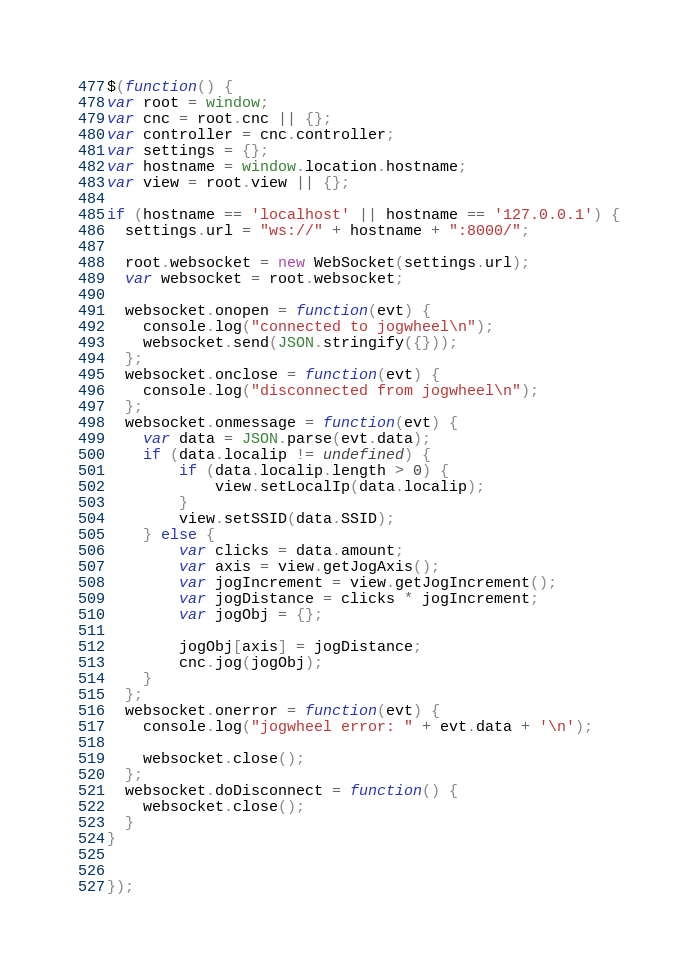<code> <loc_0><loc_0><loc_500><loc_500><_JavaScript_>$(function() {
var root = window;
var cnc = root.cnc || {};
var controller = cnc.controller;
var settings = {};
var hostname = window.location.hostname;
var view = root.view || {};

if (hostname == 'localhost' || hostname == '127.0.0.1') {
  settings.url = "ws://" + hostname + ":8000/";

  root.websocket = new WebSocket(settings.url);
  var websocket = root.websocket;

  websocket.onopen = function(evt) {
    console.log("connected to jogwheel\n");
    websocket.send(JSON.stringify({}));
  };
  websocket.onclose = function(evt) {
    console.log("disconnected from jogwheel\n");
  };
  websocket.onmessage = function(evt) {
    var data = JSON.parse(evt.data);
    if (data.localip != undefined) {
        if (data.localip.length > 0) {
            view.setLocalIp(data.localip);
        }
        view.setSSID(data.SSID);
    } else {
        var clicks = data.amount;
        var axis = view.getJogAxis();
        var jogIncrement = view.getJogIncrement();
        var jogDistance = clicks * jogIncrement;
        var jogObj = {};

        jogObj[axis] = jogDistance;
        cnc.jog(jogObj);
    }
  };
  websocket.onerror = function(evt) {
    console.log("jogwheel error: " + evt.data + '\n');

    websocket.close();
  };
  websocket.doDisconnect = function() {
    websocket.close();
  }
}


});
</code> 